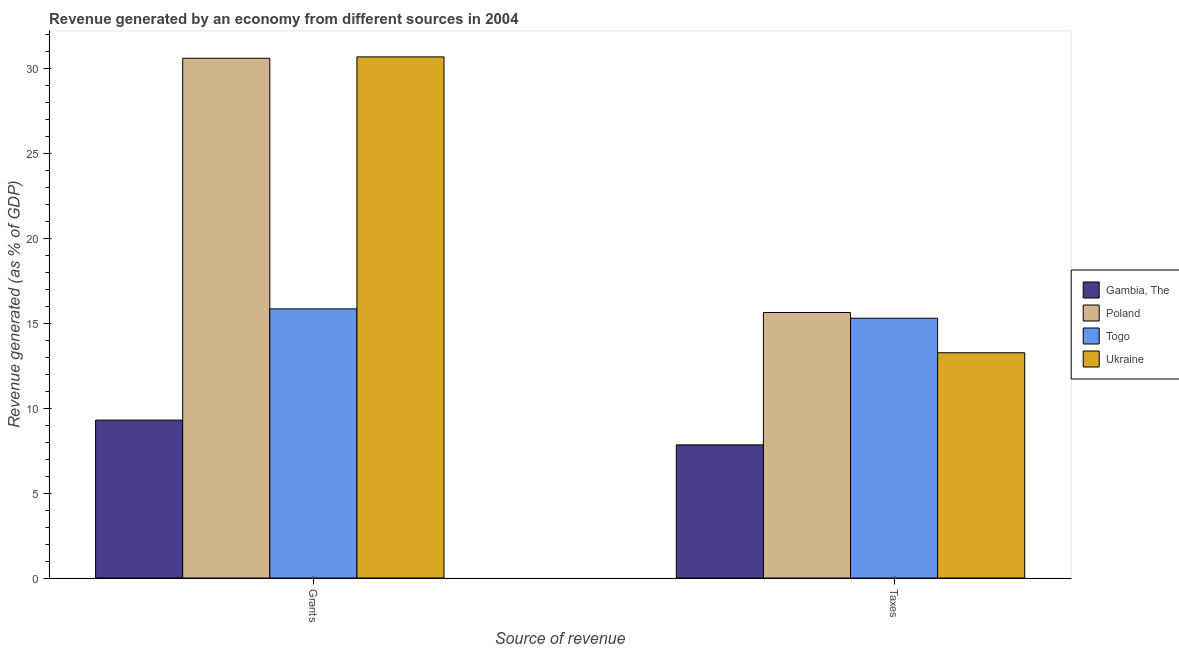How many different coloured bars are there?
Your response must be concise. 4. How many groups of bars are there?
Give a very brief answer. 2. What is the label of the 1st group of bars from the left?
Your answer should be compact. Grants. What is the revenue generated by grants in Gambia, The?
Provide a short and direct response. 9.31. Across all countries, what is the maximum revenue generated by taxes?
Offer a terse response. 15.65. Across all countries, what is the minimum revenue generated by taxes?
Keep it short and to the point. 7.85. In which country was the revenue generated by taxes maximum?
Ensure brevity in your answer.  Poland. In which country was the revenue generated by grants minimum?
Offer a very short reply. Gambia, The. What is the total revenue generated by grants in the graph?
Your answer should be compact. 86.5. What is the difference between the revenue generated by taxes in Poland and that in Ukraine?
Your answer should be very brief. 2.37. What is the difference between the revenue generated by grants in Togo and the revenue generated by taxes in Ukraine?
Provide a short and direct response. 2.58. What is the average revenue generated by taxes per country?
Keep it short and to the point. 13.02. What is the difference between the revenue generated by grants and revenue generated by taxes in Ukraine?
Your response must be concise. 17.43. What is the ratio of the revenue generated by grants in Ukraine to that in Gambia, The?
Offer a terse response. 3.3. What does the 3rd bar from the right in Taxes represents?
Provide a succinct answer. Poland. How many bars are there?
Your answer should be compact. 8. Are all the bars in the graph horizontal?
Provide a short and direct response. No. What is the difference between two consecutive major ticks on the Y-axis?
Ensure brevity in your answer.  5. Does the graph contain any zero values?
Give a very brief answer. No. Does the graph contain grids?
Ensure brevity in your answer.  No. What is the title of the graph?
Ensure brevity in your answer.  Revenue generated by an economy from different sources in 2004. Does "Burundi" appear as one of the legend labels in the graph?
Provide a short and direct response. No. What is the label or title of the X-axis?
Give a very brief answer. Source of revenue. What is the label or title of the Y-axis?
Give a very brief answer. Revenue generated (as % of GDP). What is the Revenue generated (as % of GDP) in Gambia, The in Grants?
Your answer should be very brief. 9.31. What is the Revenue generated (as % of GDP) of Poland in Grants?
Your answer should be compact. 30.63. What is the Revenue generated (as % of GDP) of Togo in Grants?
Provide a short and direct response. 15.86. What is the Revenue generated (as % of GDP) of Ukraine in Grants?
Provide a short and direct response. 30.71. What is the Revenue generated (as % of GDP) of Gambia, The in Taxes?
Give a very brief answer. 7.85. What is the Revenue generated (as % of GDP) in Poland in Taxes?
Your response must be concise. 15.65. What is the Revenue generated (as % of GDP) in Togo in Taxes?
Give a very brief answer. 15.31. What is the Revenue generated (as % of GDP) of Ukraine in Taxes?
Give a very brief answer. 13.28. Across all Source of revenue, what is the maximum Revenue generated (as % of GDP) in Gambia, The?
Offer a very short reply. 9.31. Across all Source of revenue, what is the maximum Revenue generated (as % of GDP) of Poland?
Make the answer very short. 30.63. Across all Source of revenue, what is the maximum Revenue generated (as % of GDP) in Togo?
Provide a short and direct response. 15.86. Across all Source of revenue, what is the maximum Revenue generated (as % of GDP) of Ukraine?
Your response must be concise. 30.71. Across all Source of revenue, what is the minimum Revenue generated (as % of GDP) in Gambia, The?
Your response must be concise. 7.85. Across all Source of revenue, what is the minimum Revenue generated (as % of GDP) of Poland?
Give a very brief answer. 15.65. Across all Source of revenue, what is the minimum Revenue generated (as % of GDP) in Togo?
Your response must be concise. 15.31. Across all Source of revenue, what is the minimum Revenue generated (as % of GDP) of Ukraine?
Your answer should be very brief. 13.28. What is the total Revenue generated (as % of GDP) in Gambia, The in the graph?
Provide a short and direct response. 17.16. What is the total Revenue generated (as % of GDP) of Poland in the graph?
Your answer should be very brief. 46.27. What is the total Revenue generated (as % of GDP) in Togo in the graph?
Provide a succinct answer. 31.17. What is the total Revenue generated (as % of GDP) of Ukraine in the graph?
Give a very brief answer. 43.99. What is the difference between the Revenue generated (as % of GDP) of Gambia, The in Grants and that in Taxes?
Your answer should be compact. 1.46. What is the difference between the Revenue generated (as % of GDP) in Poland in Grants and that in Taxes?
Keep it short and to the point. 14.98. What is the difference between the Revenue generated (as % of GDP) of Togo in Grants and that in Taxes?
Make the answer very short. 0.55. What is the difference between the Revenue generated (as % of GDP) in Ukraine in Grants and that in Taxes?
Ensure brevity in your answer.  17.43. What is the difference between the Revenue generated (as % of GDP) in Gambia, The in Grants and the Revenue generated (as % of GDP) in Poland in Taxes?
Your response must be concise. -6.34. What is the difference between the Revenue generated (as % of GDP) in Gambia, The in Grants and the Revenue generated (as % of GDP) in Togo in Taxes?
Ensure brevity in your answer.  -6. What is the difference between the Revenue generated (as % of GDP) in Gambia, The in Grants and the Revenue generated (as % of GDP) in Ukraine in Taxes?
Your answer should be compact. -3.97. What is the difference between the Revenue generated (as % of GDP) in Poland in Grants and the Revenue generated (as % of GDP) in Togo in Taxes?
Offer a terse response. 15.32. What is the difference between the Revenue generated (as % of GDP) in Poland in Grants and the Revenue generated (as % of GDP) in Ukraine in Taxes?
Provide a short and direct response. 17.35. What is the difference between the Revenue generated (as % of GDP) of Togo in Grants and the Revenue generated (as % of GDP) of Ukraine in Taxes?
Make the answer very short. 2.58. What is the average Revenue generated (as % of GDP) of Gambia, The per Source of revenue?
Your answer should be compact. 8.58. What is the average Revenue generated (as % of GDP) of Poland per Source of revenue?
Offer a terse response. 23.14. What is the average Revenue generated (as % of GDP) in Togo per Source of revenue?
Ensure brevity in your answer.  15.59. What is the average Revenue generated (as % of GDP) of Ukraine per Source of revenue?
Offer a very short reply. 21.99. What is the difference between the Revenue generated (as % of GDP) in Gambia, The and Revenue generated (as % of GDP) in Poland in Grants?
Keep it short and to the point. -21.32. What is the difference between the Revenue generated (as % of GDP) in Gambia, The and Revenue generated (as % of GDP) in Togo in Grants?
Your answer should be very brief. -6.55. What is the difference between the Revenue generated (as % of GDP) in Gambia, The and Revenue generated (as % of GDP) in Ukraine in Grants?
Offer a very short reply. -21.4. What is the difference between the Revenue generated (as % of GDP) of Poland and Revenue generated (as % of GDP) of Togo in Grants?
Your answer should be compact. 14.77. What is the difference between the Revenue generated (as % of GDP) in Poland and Revenue generated (as % of GDP) in Ukraine in Grants?
Keep it short and to the point. -0.08. What is the difference between the Revenue generated (as % of GDP) in Togo and Revenue generated (as % of GDP) in Ukraine in Grants?
Your answer should be compact. -14.85. What is the difference between the Revenue generated (as % of GDP) of Gambia, The and Revenue generated (as % of GDP) of Poland in Taxes?
Provide a short and direct response. -7.8. What is the difference between the Revenue generated (as % of GDP) in Gambia, The and Revenue generated (as % of GDP) in Togo in Taxes?
Keep it short and to the point. -7.46. What is the difference between the Revenue generated (as % of GDP) in Gambia, The and Revenue generated (as % of GDP) in Ukraine in Taxes?
Ensure brevity in your answer.  -5.43. What is the difference between the Revenue generated (as % of GDP) in Poland and Revenue generated (as % of GDP) in Togo in Taxes?
Give a very brief answer. 0.34. What is the difference between the Revenue generated (as % of GDP) of Poland and Revenue generated (as % of GDP) of Ukraine in Taxes?
Your answer should be very brief. 2.37. What is the difference between the Revenue generated (as % of GDP) in Togo and Revenue generated (as % of GDP) in Ukraine in Taxes?
Ensure brevity in your answer.  2.03. What is the ratio of the Revenue generated (as % of GDP) of Gambia, The in Grants to that in Taxes?
Give a very brief answer. 1.19. What is the ratio of the Revenue generated (as % of GDP) in Poland in Grants to that in Taxes?
Make the answer very short. 1.96. What is the ratio of the Revenue generated (as % of GDP) of Togo in Grants to that in Taxes?
Provide a short and direct response. 1.04. What is the ratio of the Revenue generated (as % of GDP) of Ukraine in Grants to that in Taxes?
Offer a very short reply. 2.31. What is the difference between the highest and the second highest Revenue generated (as % of GDP) of Gambia, The?
Your response must be concise. 1.46. What is the difference between the highest and the second highest Revenue generated (as % of GDP) of Poland?
Your response must be concise. 14.98. What is the difference between the highest and the second highest Revenue generated (as % of GDP) in Togo?
Your response must be concise. 0.55. What is the difference between the highest and the second highest Revenue generated (as % of GDP) of Ukraine?
Give a very brief answer. 17.43. What is the difference between the highest and the lowest Revenue generated (as % of GDP) in Gambia, The?
Provide a short and direct response. 1.46. What is the difference between the highest and the lowest Revenue generated (as % of GDP) in Poland?
Your response must be concise. 14.98. What is the difference between the highest and the lowest Revenue generated (as % of GDP) of Togo?
Your answer should be very brief. 0.55. What is the difference between the highest and the lowest Revenue generated (as % of GDP) in Ukraine?
Offer a very short reply. 17.43. 